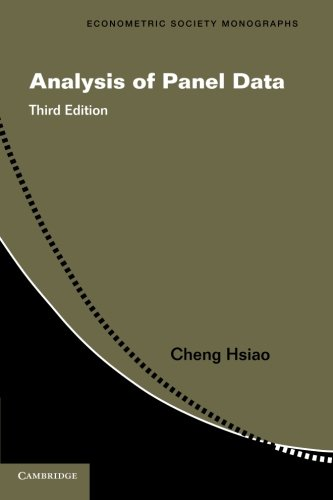Is this book related to Business & Money? Yes, this book relates to Business & Money through its discussion of econometric methods that are crucial in the analysis of economic data, important for decision making in business and financial sectors. 